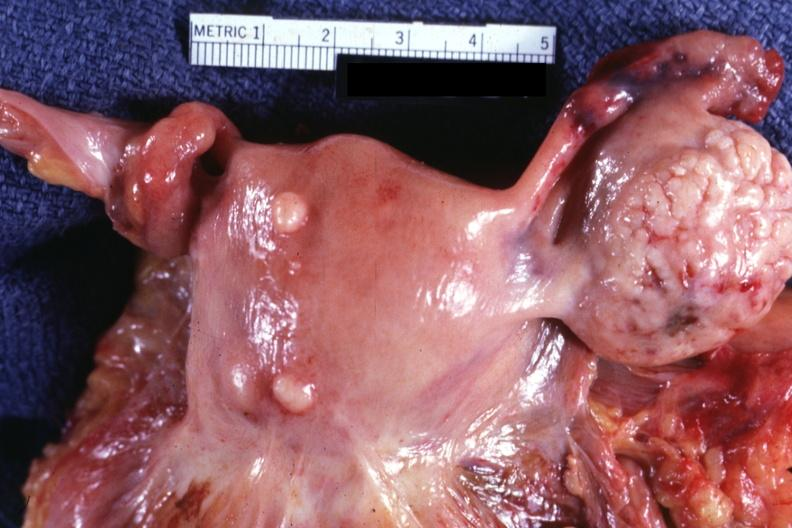re intramural one lesion small normal ovary is in photo?
Answer the question using a single word or phrase. Yes 